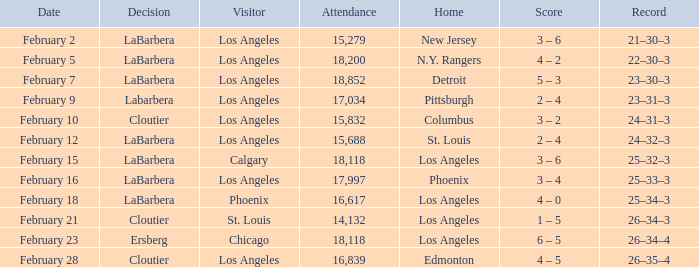What was the decision of the Kings game when Chicago was the visiting team? Ersberg. 